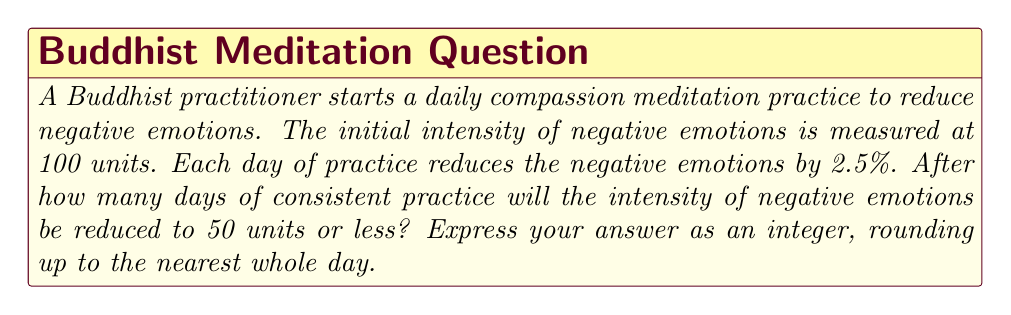Can you solve this math problem? Let's approach this step-by-step:

1) The initial intensity is 100 units, and we want to find when it reaches 50 units or less.

2) Each day, the intensity is reduced by 2.5%, which means 97.5% of the previous day's intensity remains.

3) We can express this as an exponential decay function:

   $$ I = 100 \cdot (0.975)^x $$

   Where $I$ is the intensity and $x$ is the number of days.

4) We want to solve for $x$ when $I \leq 50$:

   $$ 50 \geq 100 \cdot (0.975)^x $$

5) Dividing both sides by 100:

   $$ 0.5 \geq (0.975)^x $$

6) Taking the natural log of both sides:

   $$ \ln(0.5) \geq x \cdot \ln(0.975) $$

7) Solving for $x$:

   $$ x \geq \frac{\ln(0.5)}{\ln(0.975)} $$

8) Using a calculator:

   $$ x \geq 27.3774... $$

9) Since we need to round up to the nearest whole day, our answer is 28 days.
Answer: 28 days 